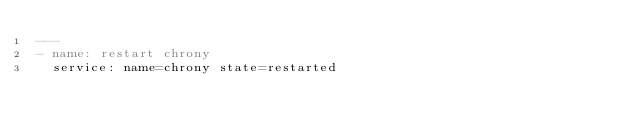<code> <loc_0><loc_0><loc_500><loc_500><_YAML_>---
- name: restart chrony
  service: name=chrony state=restarted
</code> 